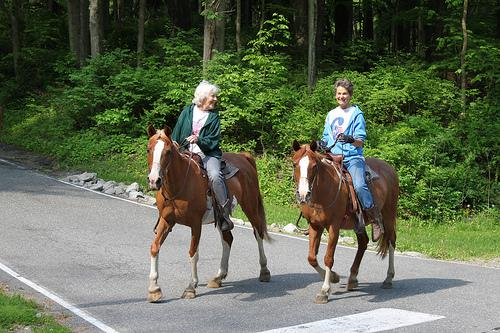Question: what animals are there?
Choices:
A. Horses.
B. Cows.
C. Pigs.
D. Goats.
Answer with the letter. Answer: A Question: what is in the background?
Choices:
A. Grass.
B. Trees.
C. Shrubs.
D. Buildings.
Answer with the letter. Answer: B Question: what pavement are they on?
Choices:
A. Sidewalk.
B. Patio.
C. Street.
D. Basketball court.
Answer with the letter. Answer: C Question: where is this scene?
Choices:
A. Farm.
B. Mountain.
C. Rural area.
D. Valley.
Answer with the letter. Answer: C Question: who is there?
Choices:
A. 2 women.
B. One man.
C. A boy.
D. A girl.
Answer with the letter. Answer: A 